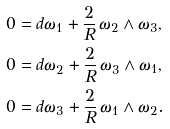<formula> <loc_0><loc_0><loc_500><loc_500>0 & = d \omega _ { 1 } + \frac { 2 } { R } \, \omega _ { 2 } \land \omega _ { 3 } , \\ 0 & = d \omega _ { 2 } + \frac { 2 } { R } \, \omega _ { 3 } \land \omega _ { 1 } , \\ 0 & = d \omega _ { 3 } + \frac { 2 } { R } \, \omega _ { 1 } \land \omega _ { 2 } .</formula> 